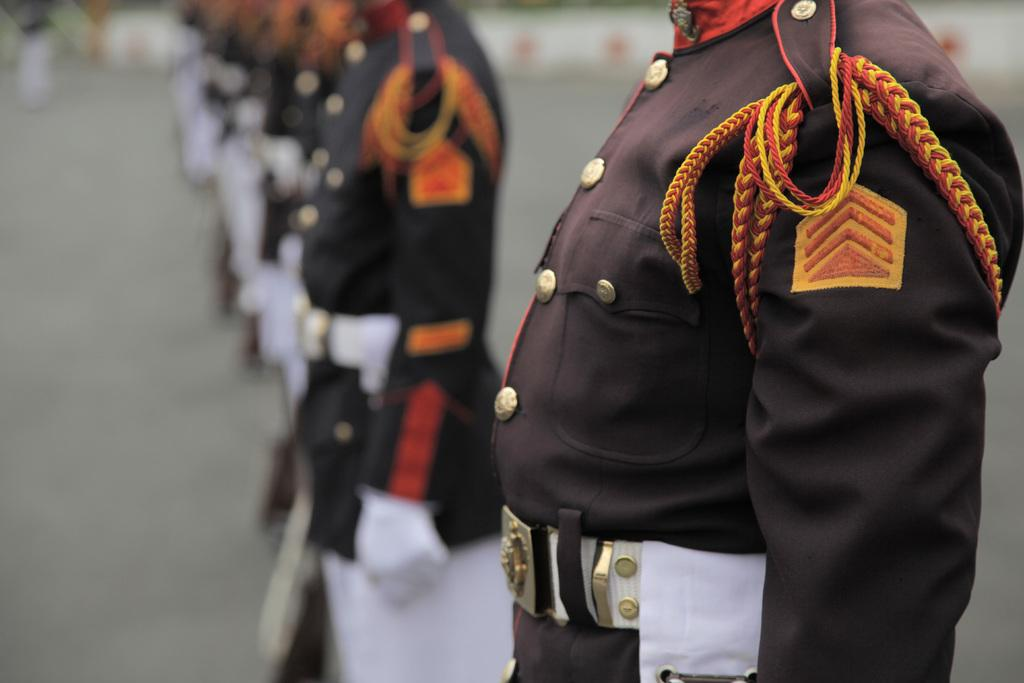Who or what can be seen in the image? There are people in the image. What are the people doing in the image? The people are standing in attention. What are the people wearing in the image? The people are wearing uniforms. What colors are the uniforms in the image? The uniforms are brown and white in color. What type of engine can be seen in the image? There is no engine present in the image. Is there a kite being flown by any of the people in the image? There is no kite visible in the image. 